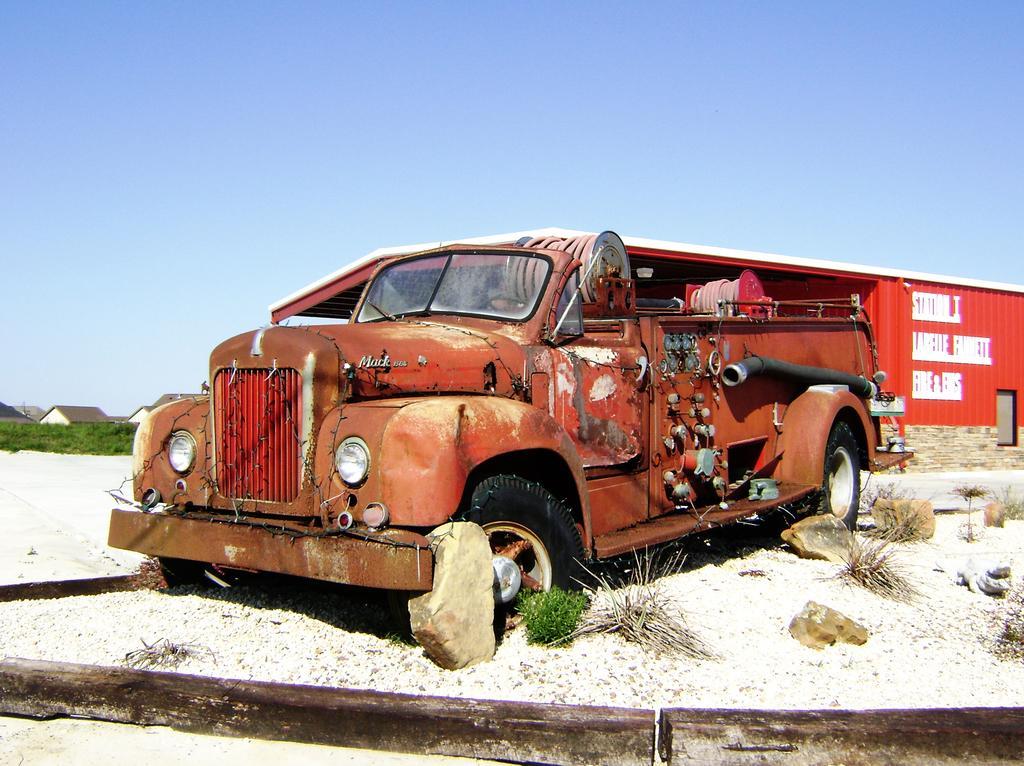In one or two sentences, can you explain what this image depicts? In this picture I can see a fire engine in the middle, in the background there is a shed, on the left side there are trees and buildings. At the top I can see the sky. 